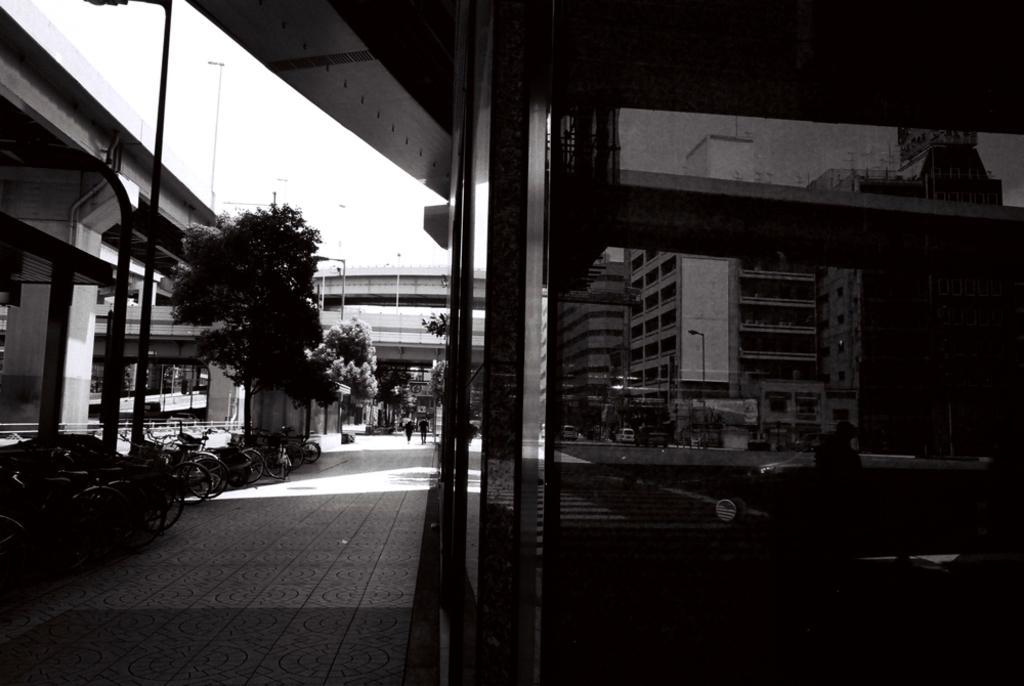Describe this image in one or two sentences. This is a black and white pic. On the left there are bicycles,vehicles on the road. In the background there are trees,light poles,bridges,buildings,windows,a hoarding,few persons and there are other objects but not clearly visible. 